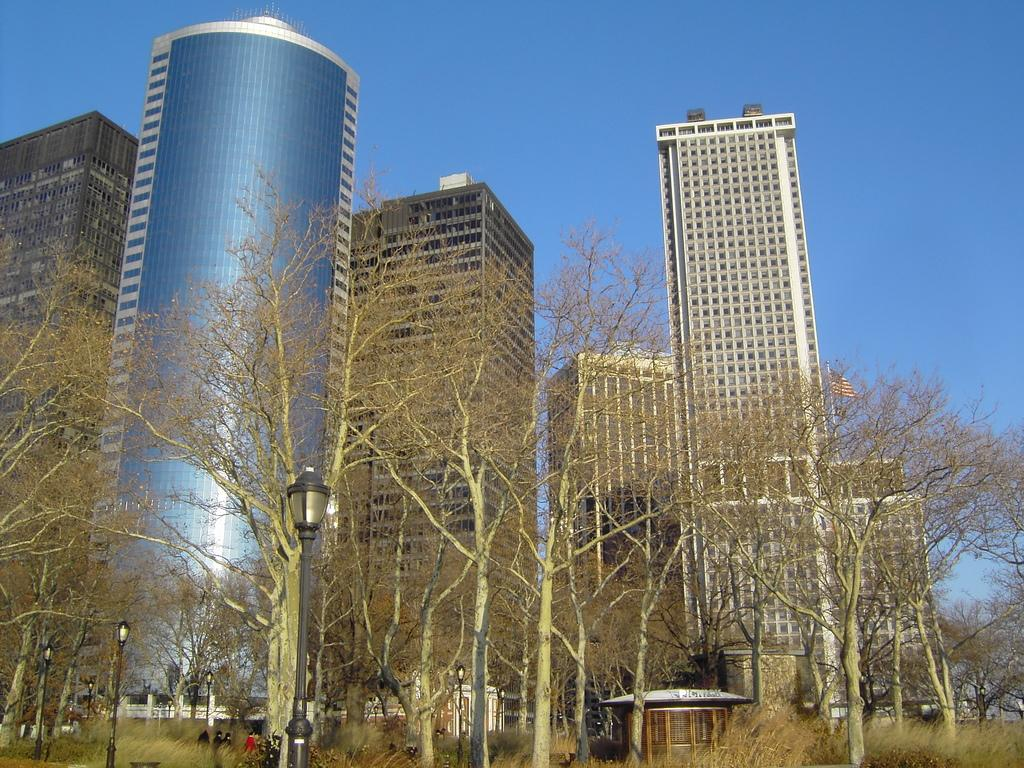What type of vertical structures can be seen in the image? There are light poles in the image. What type of natural elements are present in the image? There are trees and plants in the image. What type of man-made structures are present in the image? There are buildings, a wall, and a shed in the image. What type of symbolic object is present in the image? There is a flag in the image. Are there any living beings present in the image? Yes, there are people in the image. What part of the natural environment is visible in the background of the image? The sky is visible in the background of the image. What type of feather can be seen on the knee of the person in the image? There is no feather present on the knee of any person in the image. How does the heat affect the plants in the image? The image does not provide information about the temperature or heat, so it cannot be determined how it affects the plants. 